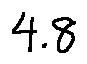Convert formula to latex. <formula><loc_0><loc_0><loc_500><loc_500>4 . 8</formula> 